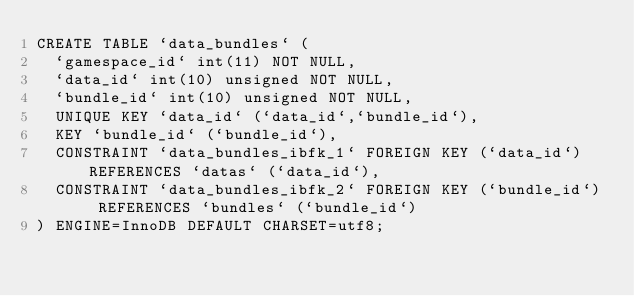<code> <loc_0><loc_0><loc_500><loc_500><_SQL_>CREATE TABLE `data_bundles` (
  `gamespace_id` int(11) NOT NULL,
  `data_id` int(10) unsigned NOT NULL,
  `bundle_id` int(10) unsigned NOT NULL,
  UNIQUE KEY `data_id` (`data_id`,`bundle_id`),
  KEY `bundle_id` (`bundle_id`),
  CONSTRAINT `data_bundles_ibfk_1` FOREIGN KEY (`data_id`) REFERENCES `datas` (`data_id`),
  CONSTRAINT `data_bundles_ibfk_2` FOREIGN KEY (`bundle_id`) REFERENCES `bundles` (`bundle_id`)
) ENGINE=InnoDB DEFAULT CHARSET=utf8;</code> 